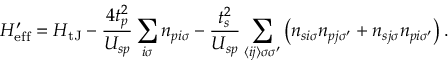<formula> <loc_0><loc_0><loc_500><loc_500>H _ { e f f } ^ { \prime } = H _ { t J } - \frac { 4 t _ { p } ^ { 2 } } { U _ { s p } } \sum _ { i \sigma } n _ { p i \sigma } - \frac { t _ { s } ^ { 2 } } { U _ { s p } } \sum _ { \langle i j \rangle \sigma \sigma ^ { \prime } } \left ( n _ { s i \sigma } n _ { p j \sigma ^ { \prime } } + n _ { s j \sigma } n _ { p i \sigma ^ { \prime } } \right ) .</formula> 